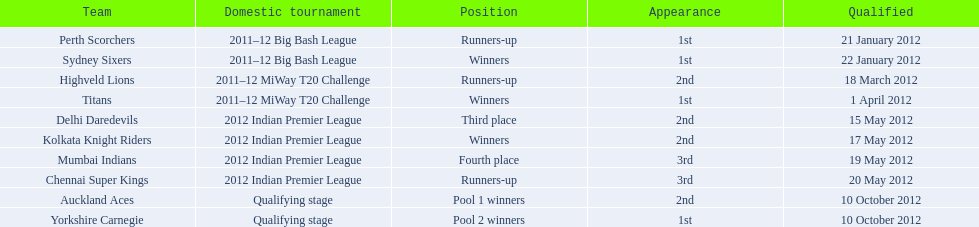Who was the champion of the 2012 indian premier league? Kolkata Knight Riders. 